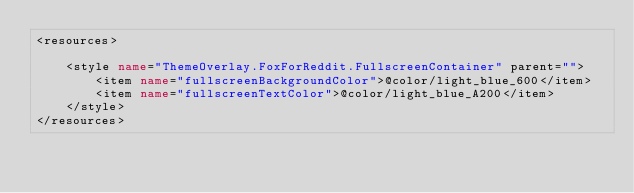<code> <loc_0><loc_0><loc_500><loc_500><_XML_><resources>

    <style name="ThemeOverlay.FoxForReddit.FullscreenContainer" parent="">
        <item name="fullscreenBackgroundColor">@color/light_blue_600</item>
        <item name="fullscreenTextColor">@color/light_blue_A200</item>
    </style>
</resources></code> 